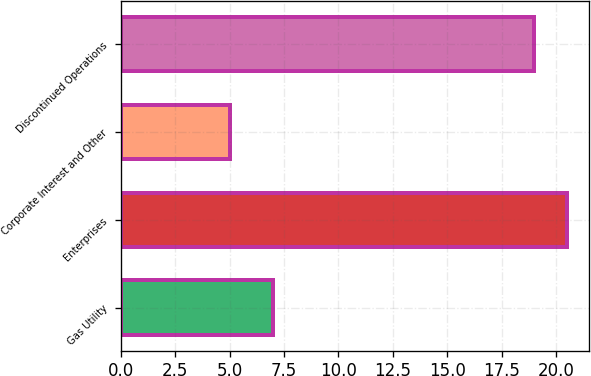Convert chart. <chart><loc_0><loc_0><loc_500><loc_500><bar_chart><fcel>Gas Utility<fcel>Enterprises<fcel>Corporate Interest and Other<fcel>Discontinued Operations<nl><fcel>7<fcel>20.5<fcel>5<fcel>19<nl></chart> 